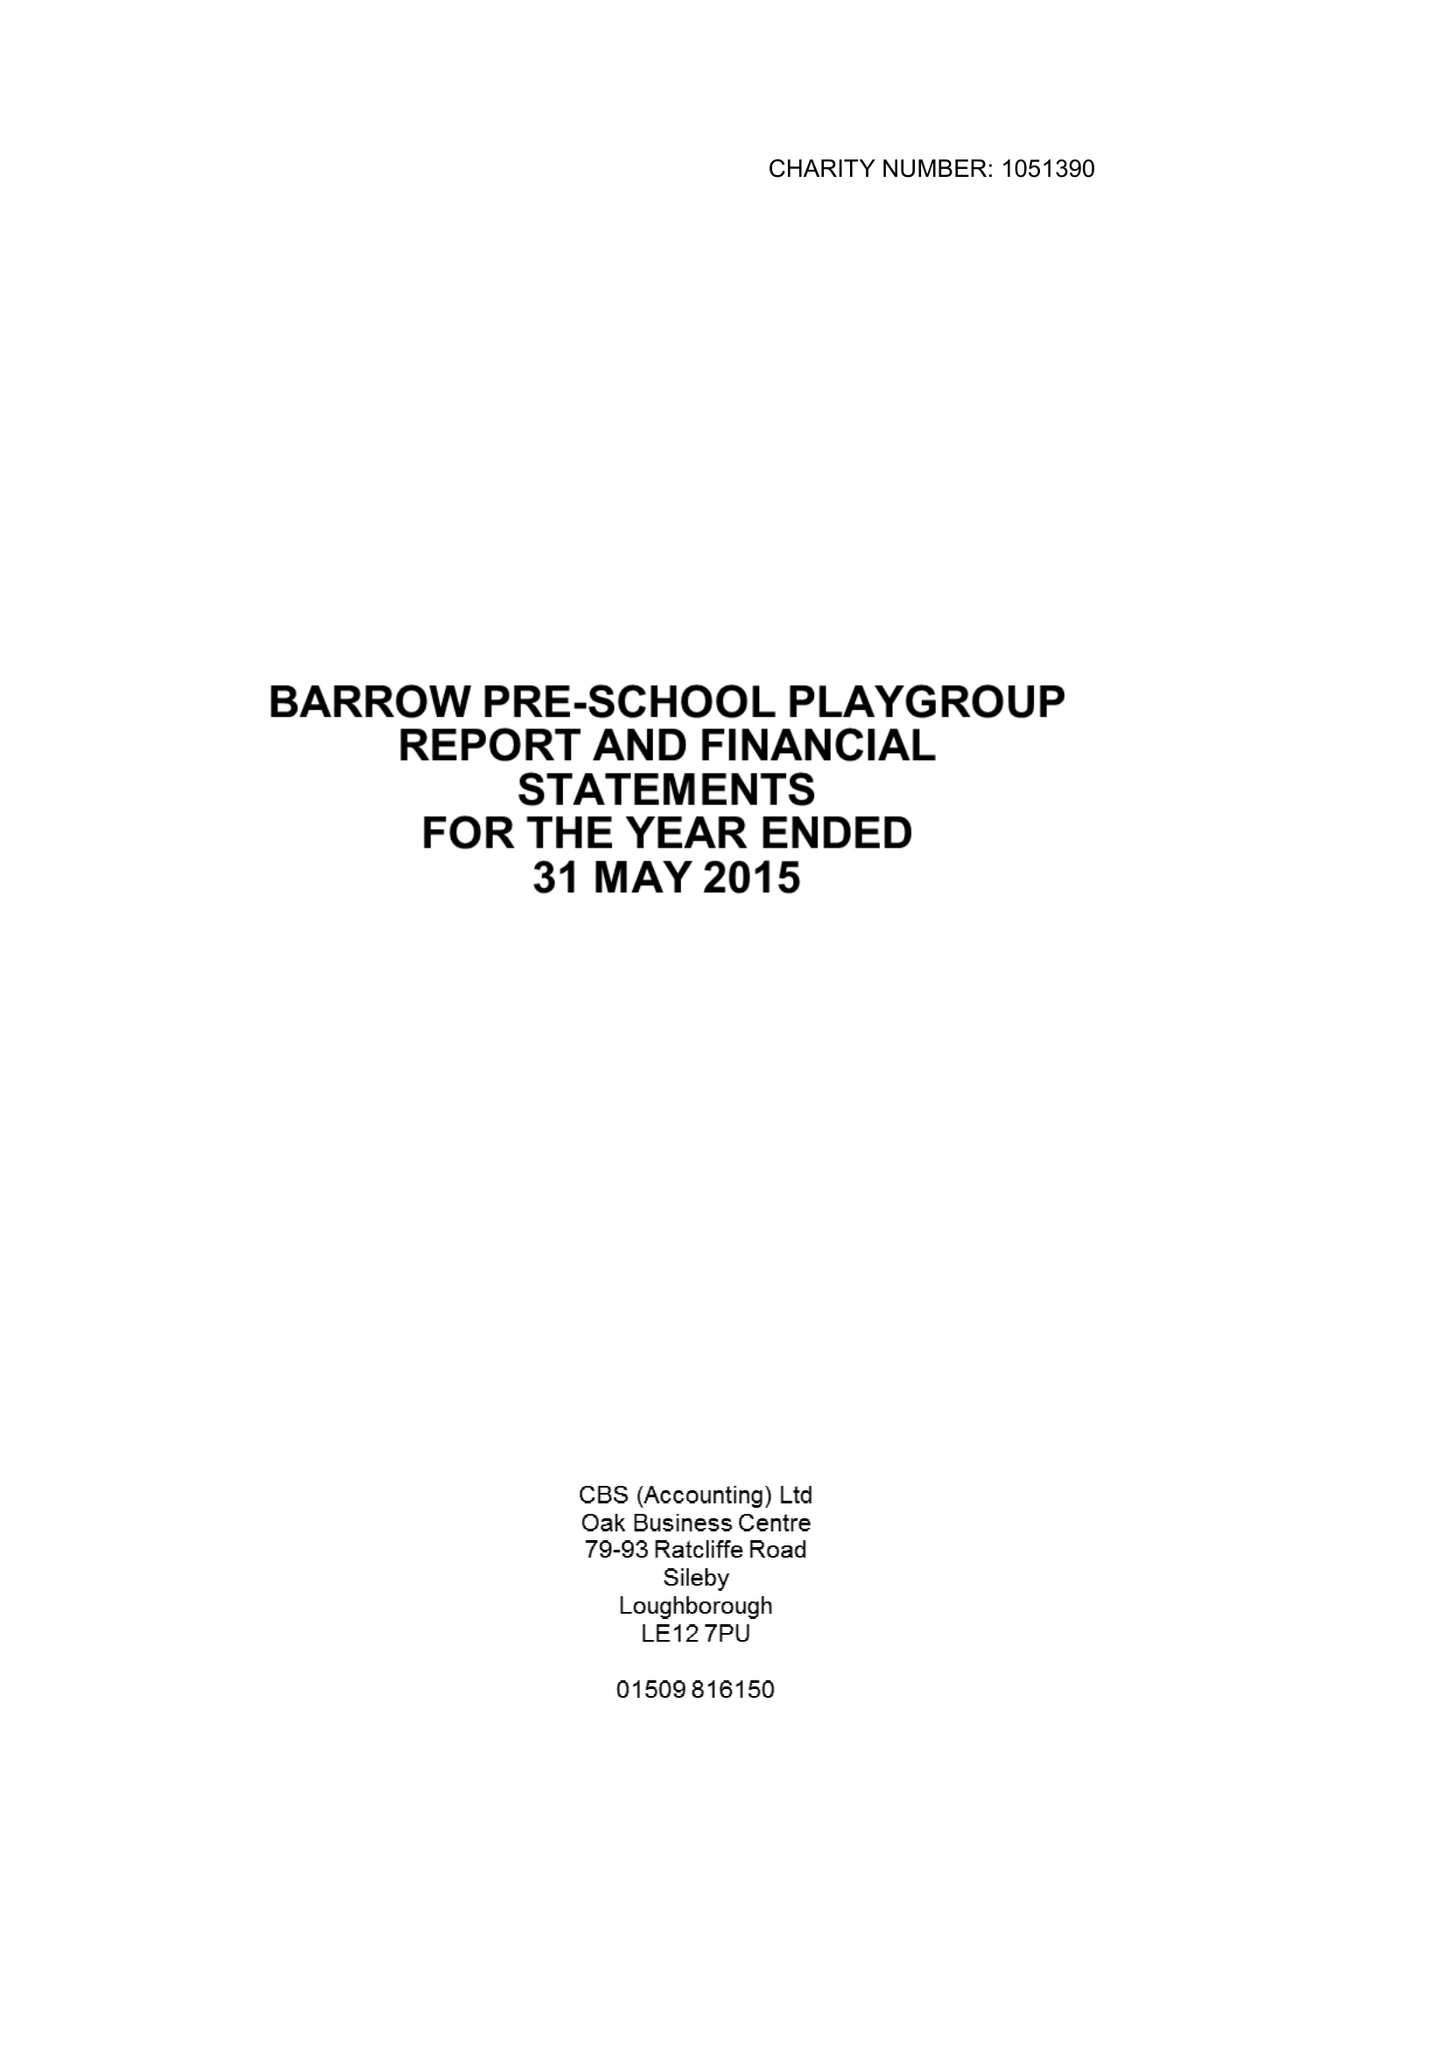What is the value for the charity_name?
Answer the question using a single word or phrase. Barrow Pre School Playgroup 